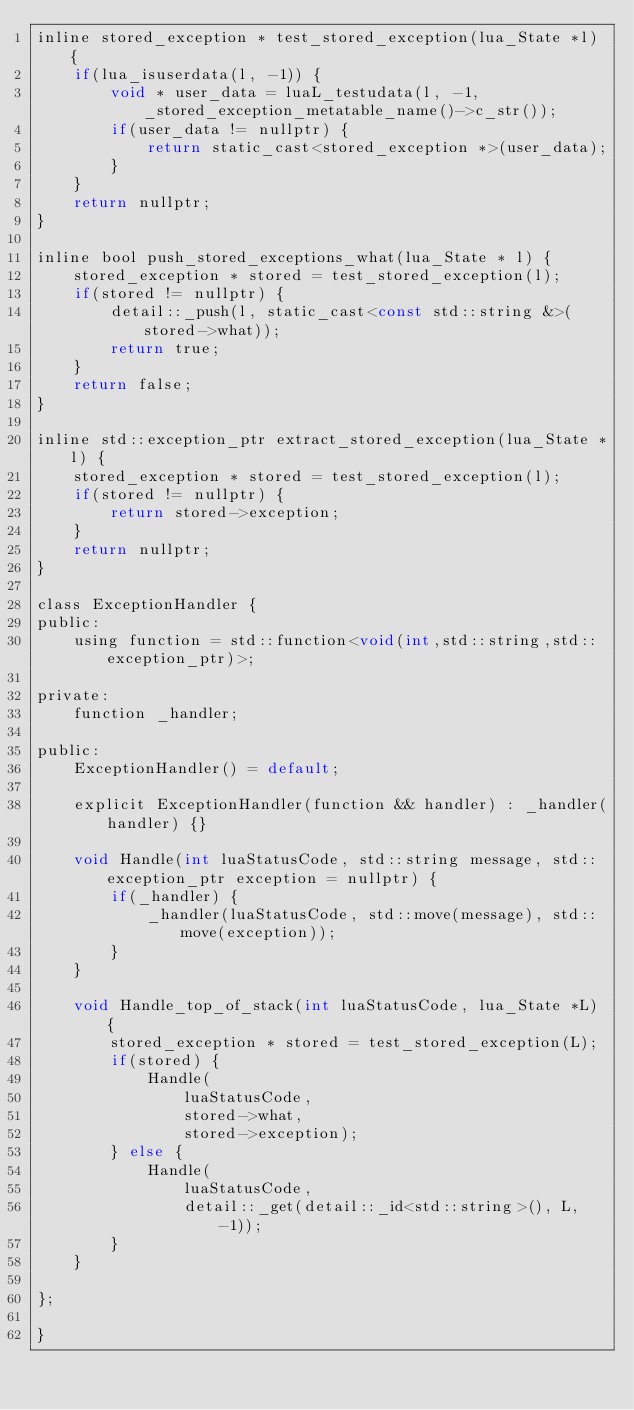Convert code to text. <code><loc_0><loc_0><loc_500><loc_500><_C_>inline stored_exception * test_stored_exception(lua_State *l) {
    if(lua_isuserdata(l, -1)) {
        void * user_data = luaL_testudata(l, -1, _stored_exception_metatable_name()->c_str());
        if(user_data != nullptr) {
            return static_cast<stored_exception *>(user_data);
        }
    }
    return nullptr;
}

inline bool push_stored_exceptions_what(lua_State * l) {
    stored_exception * stored = test_stored_exception(l);
    if(stored != nullptr) {
        detail::_push(l, static_cast<const std::string &>(stored->what));
        return true;
    }
    return false;
}

inline std::exception_ptr extract_stored_exception(lua_State *l) {
    stored_exception * stored = test_stored_exception(l);
    if(stored != nullptr) {
        return stored->exception;
    }
    return nullptr;
}

class ExceptionHandler {
public:
    using function = std::function<void(int,std::string,std::exception_ptr)>;

private:
    function _handler;

public:
    ExceptionHandler() = default;

    explicit ExceptionHandler(function && handler) : _handler(handler) {}

    void Handle(int luaStatusCode, std::string message, std::exception_ptr exception = nullptr) {
        if(_handler) {
            _handler(luaStatusCode, std::move(message), std::move(exception));
        }
    }

    void Handle_top_of_stack(int luaStatusCode, lua_State *L) {
        stored_exception * stored = test_stored_exception(L);
        if(stored) {
            Handle(
                luaStatusCode,
                stored->what,
                stored->exception);
        } else {
            Handle(
                luaStatusCode,
                detail::_get(detail::_id<std::string>(), L, -1));
        }
    }

};

}
</code> 